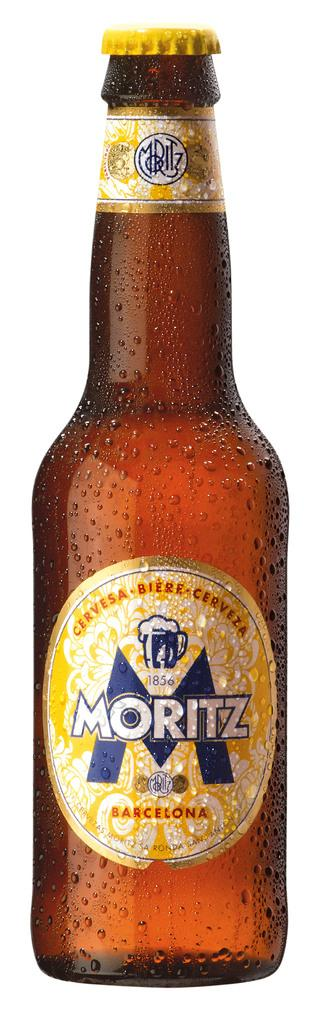<image>
Provide a brief description of the given image. bottle of sweating cold yellow label barcelona moritz beer 